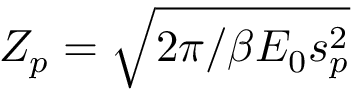<formula> <loc_0><loc_0><loc_500><loc_500>Z _ { p } = \sqrt { 2 \pi / \beta E _ { 0 } s _ { p } ^ { 2 } }</formula> 